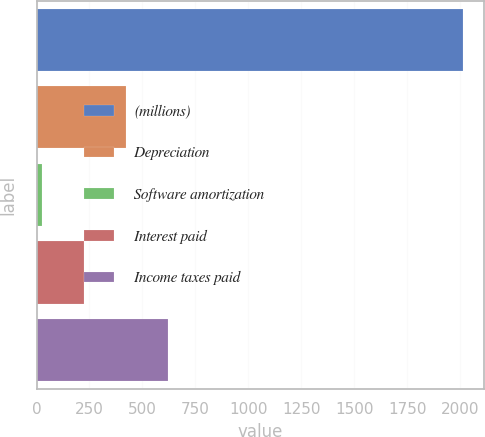Convert chart. <chart><loc_0><loc_0><loc_500><loc_500><bar_chart><fcel>(millions)<fcel>Depreciation<fcel>Software amortization<fcel>Interest paid<fcel>Income taxes paid<nl><fcel>2013<fcel>421.48<fcel>23.6<fcel>222.54<fcel>620.42<nl></chart> 